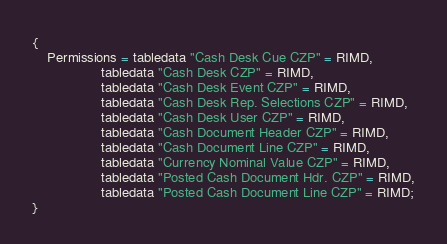<code> <loc_0><loc_0><loc_500><loc_500><_Perl_>{
    Permissions = tabledata "Cash Desk Cue CZP" = RIMD,
                  tabledata "Cash Desk CZP" = RIMD,
                  tabledata "Cash Desk Event CZP" = RIMD,
                  tabledata "Cash Desk Rep. Selections CZP" = RIMD,
                  tabledata "Cash Desk User CZP" = RIMD,
                  tabledata "Cash Document Header CZP" = RIMD,
                  tabledata "Cash Document Line CZP" = RIMD,
                  tabledata "Currency Nominal Value CZP" = RIMD,
                  tabledata "Posted Cash Document Hdr. CZP" = RIMD,
                  tabledata "Posted Cash Document Line CZP" = RIMD;
}
</code> 